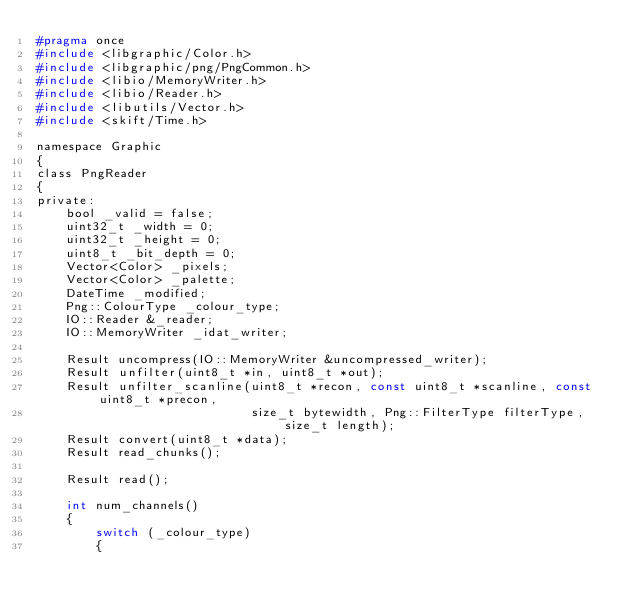Convert code to text. <code><loc_0><loc_0><loc_500><loc_500><_C_>#pragma once
#include <libgraphic/Color.h>
#include <libgraphic/png/PngCommon.h>
#include <libio/MemoryWriter.h>
#include <libio/Reader.h>
#include <libutils/Vector.h>
#include <skift/Time.h>

namespace Graphic
{
class PngReader
{
private:
    bool _valid = false;
    uint32_t _width = 0;
    uint32_t _height = 0;
    uint8_t _bit_depth = 0;
    Vector<Color> _pixels;
    Vector<Color> _palette;
    DateTime _modified;
    Png::ColourType _colour_type;
    IO::Reader &_reader;
    IO::MemoryWriter _idat_writer;

    Result uncompress(IO::MemoryWriter &uncompressed_writer);
    Result unfilter(uint8_t *in, uint8_t *out);
    Result unfilter_scanline(uint8_t *recon, const uint8_t *scanline, const uint8_t *precon,
                             size_t bytewidth, Png::FilterType filterType, size_t length);
    Result convert(uint8_t *data);
    Result read_chunks();

    Result read();

    int num_channels()
    {
        switch (_colour_type)
        {</code> 